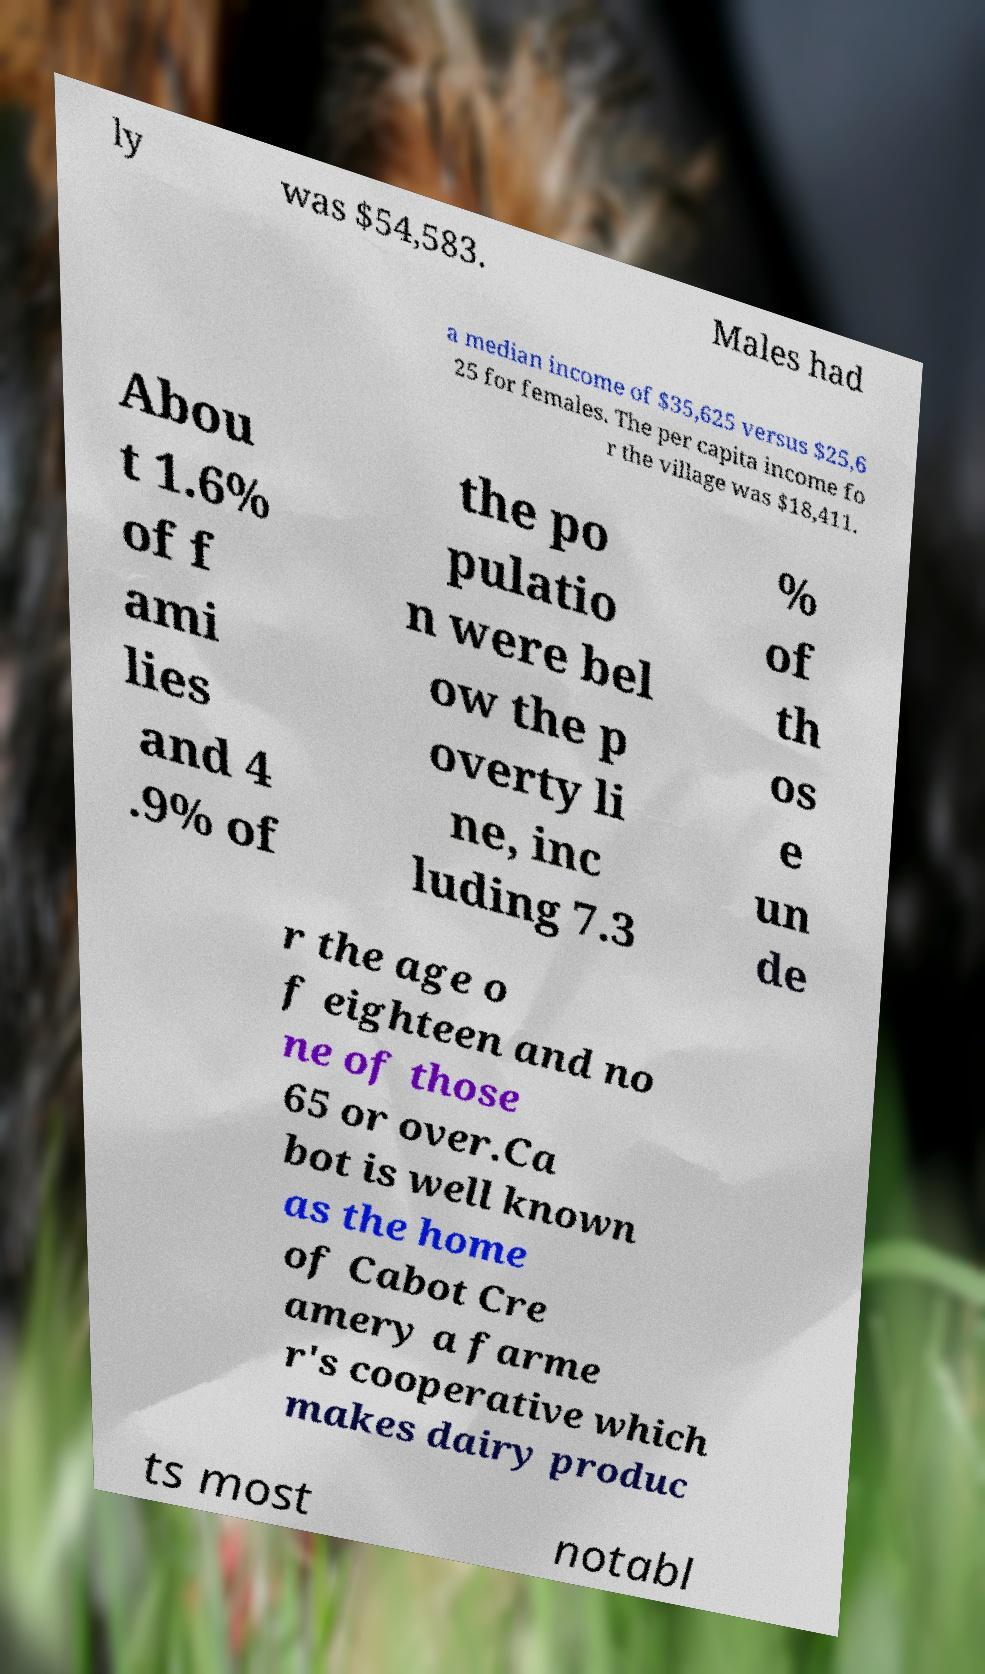Can you read and provide the text displayed in the image?This photo seems to have some interesting text. Can you extract and type it out for me? ly was $54,583. Males had a median income of $35,625 versus $25,6 25 for females. The per capita income fo r the village was $18,411. Abou t 1.6% of f ami lies and 4 .9% of the po pulatio n were bel ow the p overty li ne, inc luding 7.3 % of th os e un de r the age o f eighteen and no ne of those 65 or over.Ca bot is well known as the home of Cabot Cre amery a farme r's cooperative which makes dairy produc ts most notabl 